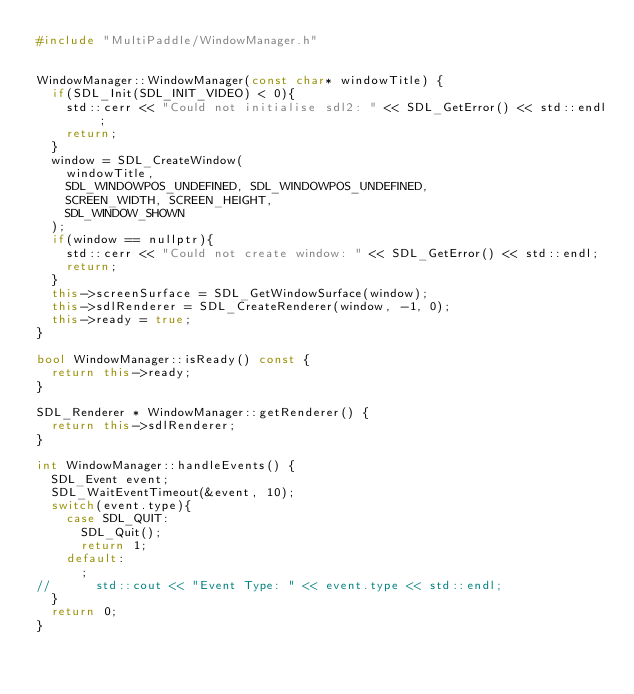Convert code to text. <code><loc_0><loc_0><loc_500><loc_500><_C++_>#include "MultiPaddle/WindowManager.h"


WindowManager::WindowManager(const char* windowTitle) {
	if(SDL_Init(SDL_INIT_VIDEO) < 0){
		std::cerr << "Could not initialise sdl2: " << SDL_GetError() << std::endl;
		return;
	}
	window = SDL_CreateWindow(
		windowTitle,
		SDL_WINDOWPOS_UNDEFINED, SDL_WINDOWPOS_UNDEFINED,
		SCREEN_WIDTH, SCREEN_HEIGHT,
		SDL_WINDOW_SHOWN
	);
	if(window == nullptr){
		std::cerr << "Could not create window: " << SDL_GetError() << std::endl;
		return;
	}
	this->screenSurface = SDL_GetWindowSurface(window);
	this->sdlRenderer = SDL_CreateRenderer(window, -1, 0);
	this->ready = true;
}

bool WindowManager::isReady() const {
	return this->ready;
}

SDL_Renderer * WindowManager::getRenderer() {
	return this->sdlRenderer;
}

int WindowManager::handleEvents() {
	SDL_Event event;
	SDL_WaitEventTimeout(&event, 10);
	switch(event.type){
		case SDL_QUIT:
			SDL_Quit();
			return 1;
		default:
			;
//			std::cout << "Event Type: " << event.type << std::endl;
	}
	return 0;
}
</code> 